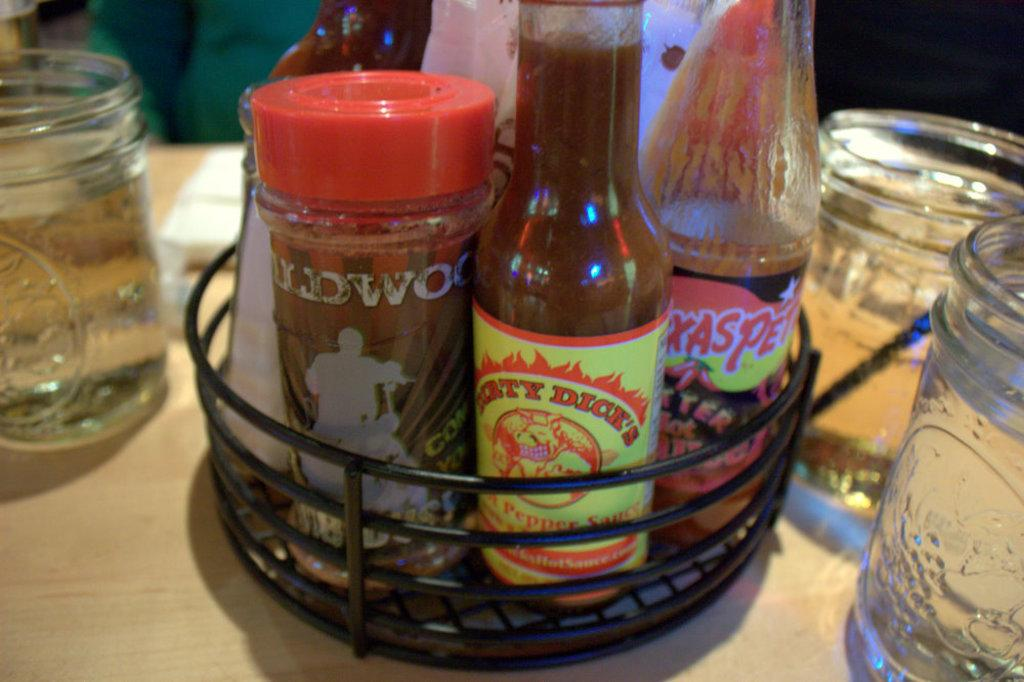What type of containers are present in the image? There are sauce bottles in the image. What other items can be seen on the table? There are glass tumblers in the image. Where are the sauce bottles and glass tumblers located? The sauce bottles and glass tumblers are placed on a table. What type of fruit is present on the table in the image? There is no fruit, specifically oranges, present on the table in the image. 